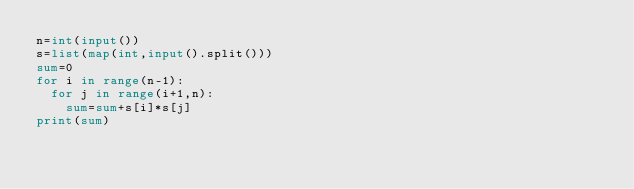<code> <loc_0><loc_0><loc_500><loc_500><_Python_>n=int(input())
s=list(map(int,input().split()))
sum=0
for i in range(n-1):
  for j in range(i+1,n):
    sum=sum+s[i]*s[j]
print(sum)</code> 